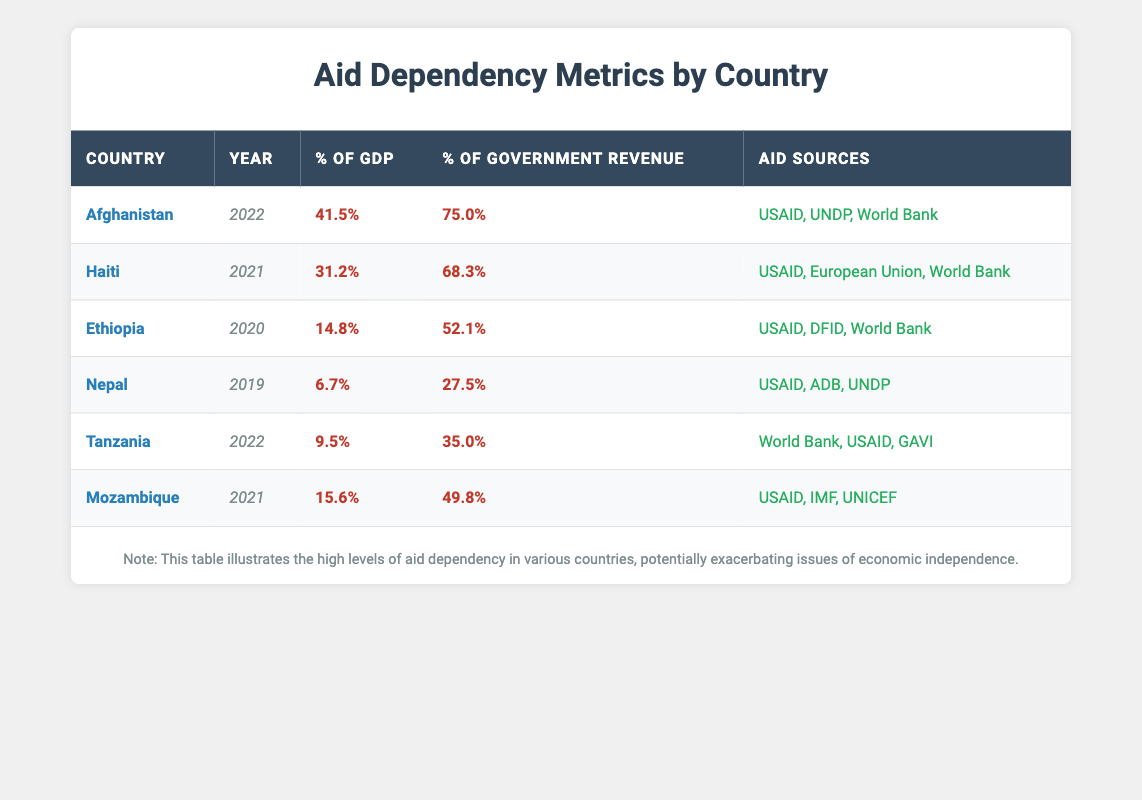What is the percentage of GDP for Afghanistan in 2022? Afghanistan's GDP percentage for 2022 is listed in the table under the respective column for that year. It shows 41.5%.
Answer: 41.5% Which country had the highest percentage of government revenue dependency on aid in the years provided? To determine which country had the highest government revenue dependency on aid, we compare the percentage values in that column. Afghanistan at 75.0% in 2022 has the highest percentage.
Answer: Afghanistan What is the average aid dependency percentage of GDP for the years available? We sum the percentages of GDP: (41.5 + 31.2 + 14.8 + 6.7 + 9.5 + 15.6) = 118.3. There are 6 data points, so the average is 118.3/6 ≈ 19.72.
Answer: 19.72 Is Mozambique's aid dependency on government revenue higher than Tanzania's in 2022? Mozambique's percentage of government revenue from aid in 2021 is 49.8%, while Tanzania's in 2022 is 35.0%. Since 49.8% is greater than 35.0%, the statement is true.
Answer: Yes How does Ethiopia's aid dependency compare to Nepal's in terms of government revenue? Ethiopia has a government revenue dependency of 52.1% in 2020, while Nepal has a dependency of 27.5% in 2019. Since 52.1% > 27.5%, Ethiopia's dependency is higher.
Answer: Ethiopia Which country received aid from the European Union according to the table? The aid sources are listed, and comparing them shows that Haiti received aid from the European Union in 2021.
Answer: Haiti How much lower is the percentage of GDP for Nepal compared to Afghanistan? To find this, we subtract Nepal's GDP percentage (6.7%) from Afghanistan's (41.5%): 41.5% - 6.7% = 34.8%.
Answer: 34.8% Are all the countries in the table receiving aid from USAID? By examining the aid sources for each country, we see that all listed countries (Afghanistan, Haiti, Ethiopia, Nepal, Tanzania, Mozambique) have USAID as an aid source.
Answer: Yes 